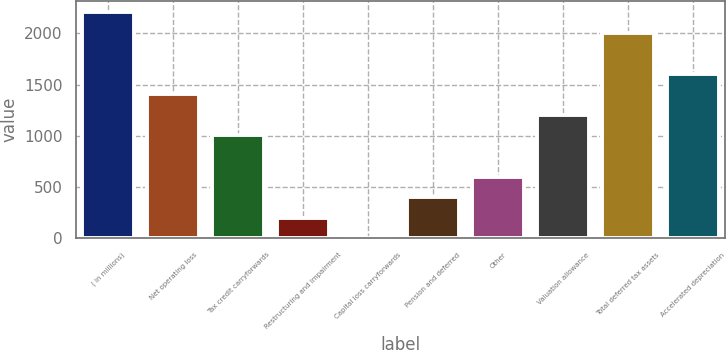Convert chart to OTSL. <chart><loc_0><loc_0><loc_500><loc_500><bar_chart><fcel>( in millions)<fcel>Net operating loss<fcel>Tax credit carryforwards<fcel>Restructuring and impairment<fcel>Capital loss carryforwards<fcel>Pension and deferred<fcel>Other<fcel>Valuation allowance<fcel>Total deferred tax assets<fcel>Accelerated depreciation<nl><fcel>2207.56<fcel>1405.32<fcel>1004.2<fcel>201.96<fcel>1.4<fcel>402.52<fcel>603.08<fcel>1204.76<fcel>2007<fcel>1605.88<nl></chart> 